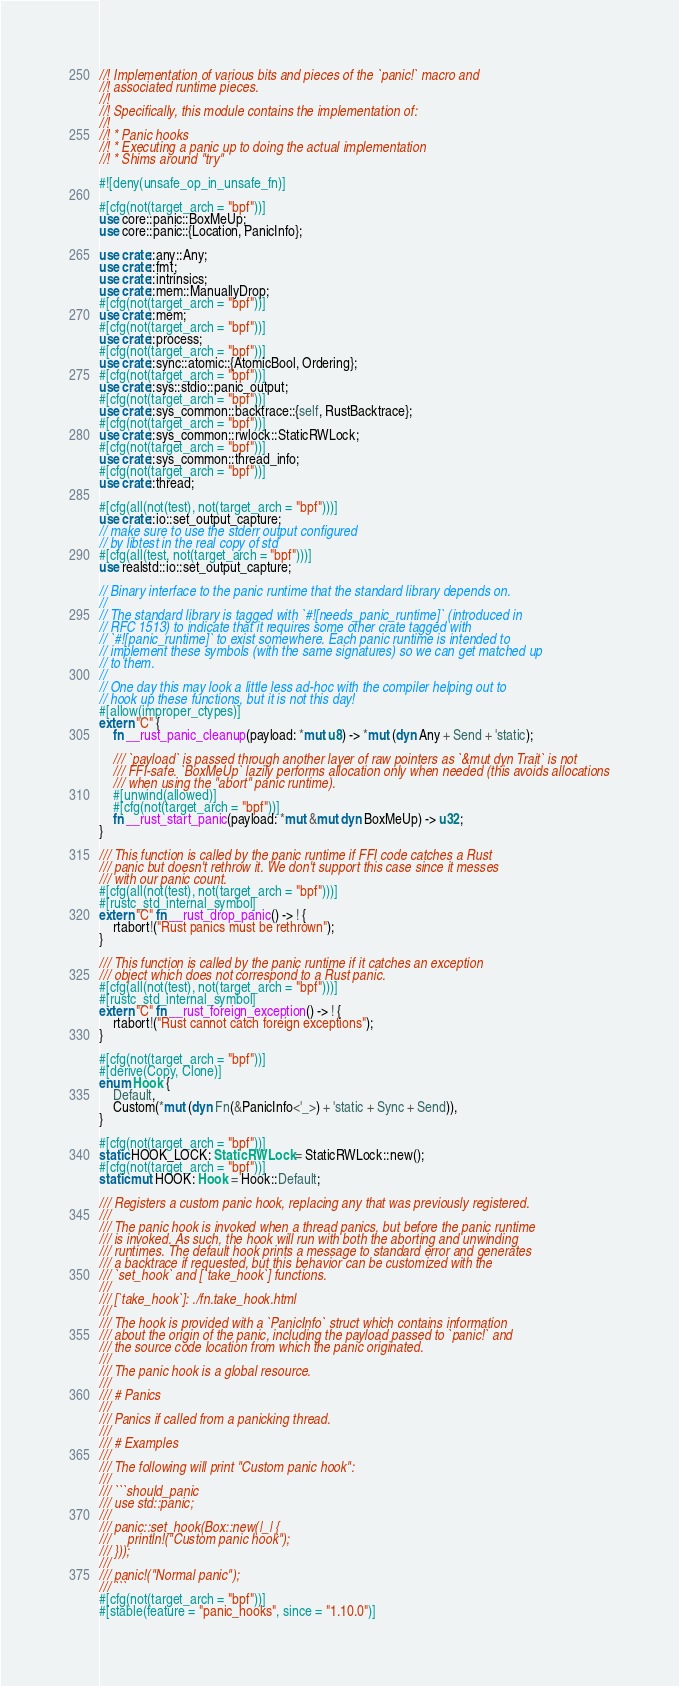<code> <loc_0><loc_0><loc_500><loc_500><_Rust_>//! Implementation of various bits and pieces of the `panic!` macro and
//! associated runtime pieces.
//!
//! Specifically, this module contains the implementation of:
//!
//! * Panic hooks
//! * Executing a panic up to doing the actual implementation
//! * Shims around "try"

#![deny(unsafe_op_in_unsafe_fn)]

#[cfg(not(target_arch = "bpf"))]
use core::panic::BoxMeUp;
use core::panic::{Location, PanicInfo};

use crate::any::Any;
use crate::fmt;
use crate::intrinsics;
use crate::mem::ManuallyDrop;
#[cfg(not(target_arch = "bpf"))]
use crate::mem;
#[cfg(not(target_arch = "bpf"))]
use crate::process;
#[cfg(not(target_arch = "bpf"))]
use crate::sync::atomic::{AtomicBool, Ordering};
#[cfg(not(target_arch = "bpf"))]
use crate::sys::stdio::panic_output;
#[cfg(not(target_arch = "bpf"))]
use crate::sys_common::backtrace::{self, RustBacktrace};
#[cfg(not(target_arch = "bpf"))]
use crate::sys_common::rwlock::StaticRWLock;
#[cfg(not(target_arch = "bpf"))]
use crate::sys_common::thread_info;
#[cfg(not(target_arch = "bpf"))]
use crate::thread;

#[cfg(all(not(test), not(target_arch = "bpf")))]
use crate::io::set_output_capture;
// make sure to use the stderr output configured
// by libtest in the real copy of std
#[cfg(all(test, not(target_arch = "bpf")))]
use realstd::io::set_output_capture;

// Binary interface to the panic runtime that the standard library depends on.
//
// The standard library is tagged with `#![needs_panic_runtime]` (introduced in
// RFC 1513) to indicate that it requires some other crate tagged with
// `#![panic_runtime]` to exist somewhere. Each panic runtime is intended to
// implement these symbols (with the same signatures) so we can get matched up
// to them.
//
// One day this may look a little less ad-hoc with the compiler helping out to
// hook up these functions, but it is not this day!
#[allow(improper_ctypes)]
extern "C" {
    fn __rust_panic_cleanup(payload: *mut u8) -> *mut (dyn Any + Send + 'static);

    /// `payload` is passed through another layer of raw pointers as `&mut dyn Trait` is not
    /// FFI-safe. `BoxMeUp` lazily performs allocation only when needed (this avoids allocations
    /// when using the "abort" panic runtime).
    #[unwind(allowed)]
    #[cfg(not(target_arch = "bpf"))]
    fn __rust_start_panic(payload: *mut &mut dyn BoxMeUp) -> u32;
}

/// This function is called by the panic runtime if FFI code catches a Rust
/// panic but doesn't rethrow it. We don't support this case since it messes
/// with our panic count.
#[cfg(all(not(test), not(target_arch = "bpf")))]
#[rustc_std_internal_symbol]
extern "C" fn __rust_drop_panic() -> ! {
    rtabort!("Rust panics must be rethrown");
}

/// This function is called by the panic runtime if it catches an exception
/// object which does not correspond to a Rust panic.
#[cfg(all(not(test), not(target_arch = "bpf")))]
#[rustc_std_internal_symbol]
extern "C" fn __rust_foreign_exception() -> ! {
    rtabort!("Rust cannot catch foreign exceptions");
}

#[cfg(not(target_arch = "bpf"))]
#[derive(Copy, Clone)]
enum Hook {
    Default,
    Custom(*mut (dyn Fn(&PanicInfo<'_>) + 'static + Sync + Send)),
}

#[cfg(not(target_arch = "bpf"))]
static HOOK_LOCK: StaticRWLock = StaticRWLock::new();
#[cfg(not(target_arch = "bpf"))]
static mut HOOK: Hook = Hook::Default;

/// Registers a custom panic hook, replacing any that was previously registered.
///
/// The panic hook is invoked when a thread panics, but before the panic runtime
/// is invoked. As such, the hook will run with both the aborting and unwinding
/// runtimes. The default hook prints a message to standard error and generates
/// a backtrace if requested, but this behavior can be customized with the
/// `set_hook` and [`take_hook`] functions.
///
/// [`take_hook`]: ./fn.take_hook.html
///
/// The hook is provided with a `PanicInfo` struct which contains information
/// about the origin of the panic, including the payload passed to `panic!` and
/// the source code location from which the panic originated.
///
/// The panic hook is a global resource.
///
/// # Panics
///
/// Panics if called from a panicking thread.
///
/// # Examples
///
/// The following will print "Custom panic hook":
///
/// ```should_panic
/// use std::panic;
///
/// panic::set_hook(Box::new(|_| {
///     println!("Custom panic hook");
/// }));
///
/// panic!("Normal panic");
/// ```
#[cfg(not(target_arch = "bpf"))]
#[stable(feature = "panic_hooks", since = "1.10.0")]</code> 